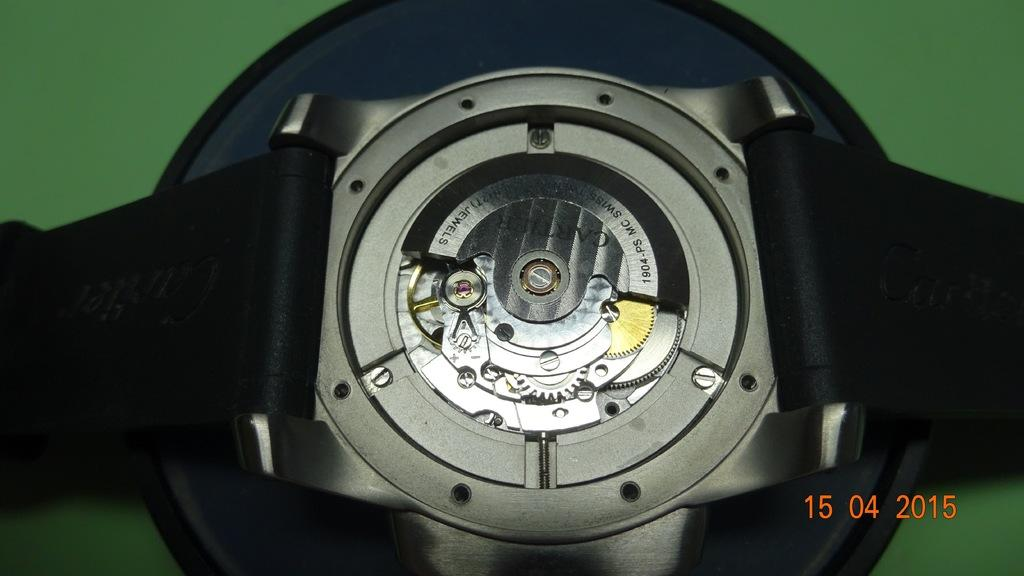Provide a one-sentence caption for the provided image. The workings of a watch are shown with a 2015 time stamp in the corner. 